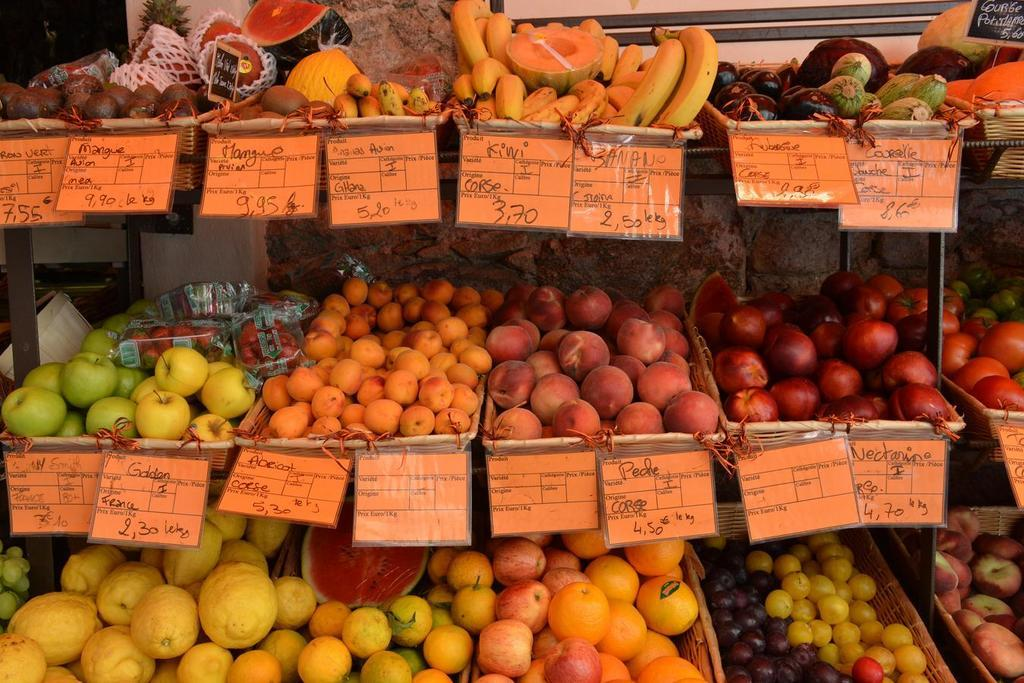What type of food can be seen in the image? There are fruits arranged in baskets in the image. What else is present in the image besides the fruits? There are boards with text in the image. How does the daughter contribute to the pollution in the image? There is no daughter present in the image, and therefore no such contribution can be observed. 